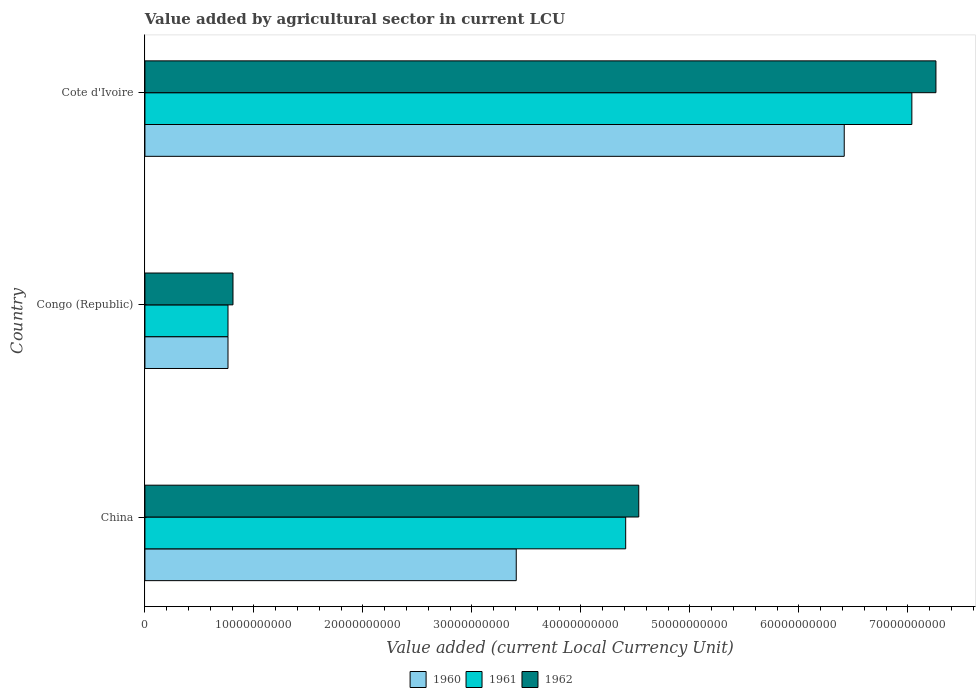Are the number of bars per tick equal to the number of legend labels?
Make the answer very short. Yes. How many bars are there on the 1st tick from the top?
Your answer should be compact. 3. How many bars are there on the 2nd tick from the bottom?
Ensure brevity in your answer.  3. What is the label of the 2nd group of bars from the top?
Your response must be concise. Congo (Republic). What is the value added by agricultural sector in 1960 in China?
Your answer should be compact. 3.41e+1. Across all countries, what is the maximum value added by agricultural sector in 1960?
Your answer should be compact. 6.42e+1. Across all countries, what is the minimum value added by agricultural sector in 1961?
Keep it short and to the point. 7.62e+09. In which country was the value added by agricultural sector in 1961 maximum?
Provide a succinct answer. Cote d'Ivoire. In which country was the value added by agricultural sector in 1961 minimum?
Your answer should be compact. Congo (Republic). What is the total value added by agricultural sector in 1961 in the graph?
Provide a short and direct response. 1.22e+11. What is the difference between the value added by agricultural sector in 1961 in Congo (Republic) and that in Cote d'Ivoire?
Your answer should be very brief. -6.27e+1. What is the difference between the value added by agricultural sector in 1960 in Congo (Republic) and the value added by agricultural sector in 1961 in Cote d'Ivoire?
Give a very brief answer. -6.27e+1. What is the average value added by agricultural sector in 1962 per country?
Your answer should be very brief. 4.20e+1. What is the ratio of the value added by agricultural sector in 1962 in China to that in Congo (Republic)?
Provide a succinct answer. 5.61. What is the difference between the highest and the second highest value added by agricultural sector in 1961?
Offer a very short reply. 2.63e+1. What is the difference between the highest and the lowest value added by agricultural sector in 1962?
Give a very brief answer. 6.45e+1. What does the 1st bar from the top in Cote d'Ivoire represents?
Ensure brevity in your answer.  1962. How many bars are there?
Your response must be concise. 9. Are all the bars in the graph horizontal?
Your answer should be compact. Yes. Does the graph contain grids?
Make the answer very short. No. How are the legend labels stacked?
Your answer should be compact. Horizontal. What is the title of the graph?
Make the answer very short. Value added by agricultural sector in current LCU. What is the label or title of the X-axis?
Keep it short and to the point. Value added (current Local Currency Unit). What is the Value added (current Local Currency Unit) of 1960 in China?
Offer a terse response. 3.41e+1. What is the Value added (current Local Currency Unit) in 1961 in China?
Provide a succinct answer. 4.41e+1. What is the Value added (current Local Currency Unit) of 1962 in China?
Your answer should be very brief. 4.53e+1. What is the Value added (current Local Currency Unit) in 1960 in Congo (Republic)?
Provide a succinct answer. 7.62e+09. What is the Value added (current Local Currency Unit) in 1961 in Congo (Republic)?
Ensure brevity in your answer.  7.62e+09. What is the Value added (current Local Currency Unit) of 1962 in Congo (Republic)?
Offer a very short reply. 8.08e+09. What is the Value added (current Local Currency Unit) in 1960 in Cote d'Ivoire?
Provide a short and direct response. 6.42e+1. What is the Value added (current Local Currency Unit) of 1961 in Cote d'Ivoire?
Your answer should be compact. 7.04e+1. What is the Value added (current Local Currency Unit) in 1962 in Cote d'Ivoire?
Give a very brief answer. 7.26e+1. Across all countries, what is the maximum Value added (current Local Currency Unit) in 1960?
Give a very brief answer. 6.42e+1. Across all countries, what is the maximum Value added (current Local Currency Unit) in 1961?
Make the answer very short. 7.04e+1. Across all countries, what is the maximum Value added (current Local Currency Unit) in 1962?
Give a very brief answer. 7.26e+1. Across all countries, what is the minimum Value added (current Local Currency Unit) in 1960?
Provide a succinct answer. 7.62e+09. Across all countries, what is the minimum Value added (current Local Currency Unit) in 1961?
Provide a succinct answer. 7.62e+09. Across all countries, what is the minimum Value added (current Local Currency Unit) in 1962?
Your answer should be compact. 8.08e+09. What is the total Value added (current Local Currency Unit) of 1960 in the graph?
Make the answer very short. 1.06e+11. What is the total Value added (current Local Currency Unit) in 1961 in the graph?
Provide a short and direct response. 1.22e+11. What is the total Value added (current Local Currency Unit) in 1962 in the graph?
Offer a very short reply. 1.26e+11. What is the difference between the Value added (current Local Currency Unit) in 1960 in China and that in Congo (Republic)?
Ensure brevity in your answer.  2.64e+1. What is the difference between the Value added (current Local Currency Unit) of 1961 in China and that in Congo (Republic)?
Offer a terse response. 3.65e+1. What is the difference between the Value added (current Local Currency Unit) of 1962 in China and that in Congo (Republic)?
Your response must be concise. 3.72e+1. What is the difference between the Value added (current Local Currency Unit) in 1960 in China and that in Cote d'Ivoire?
Keep it short and to the point. -3.01e+1. What is the difference between the Value added (current Local Currency Unit) of 1961 in China and that in Cote d'Ivoire?
Your answer should be very brief. -2.63e+1. What is the difference between the Value added (current Local Currency Unit) in 1962 in China and that in Cote d'Ivoire?
Your response must be concise. -2.73e+1. What is the difference between the Value added (current Local Currency Unit) in 1960 in Congo (Republic) and that in Cote d'Ivoire?
Your answer should be compact. -5.65e+1. What is the difference between the Value added (current Local Currency Unit) in 1961 in Congo (Republic) and that in Cote d'Ivoire?
Provide a succinct answer. -6.27e+1. What is the difference between the Value added (current Local Currency Unit) of 1962 in Congo (Republic) and that in Cote d'Ivoire?
Provide a succinct answer. -6.45e+1. What is the difference between the Value added (current Local Currency Unit) in 1960 in China and the Value added (current Local Currency Unit) in 1961 in Congo (Republic)?
Offer a terse response. 2.64e+1. What is the difference between the Value added (current Local Currency Unit) in 1960 in China and the Value added (current Local Currency Unit) in 1962 in Congo (Republic)?
Offer a terse response. 2.60e+1. What is the difference between the Value added (current Local Currency Unit) in 1961 in China and the Value added (current Local Currency Unit) in 1962 in Congo (Republic)?
Your answer should be compact. 3.60e+1. What is the difference between the Value added (current Local Currency Unit) in 1960 in China and the Value added (current Local Currency Unit) in 1961 in Cote d'Ivoire?
Offer a very short reply. -3.63e+1. What is the difference between the Value added (current Local Currency Unit) in 1960 in China and the Value added (current Local Currency Unit) in 1962 in Cote d'Ivoire?
Provide a short and direct response. -3.85e+1. What is the difference between the Value added (current Local Currency Unit) in 1961 in China and the Value added (current Local Currency Unit) in 1962 in Cote d'Ivoire?
Give a very brief answer. -2.85e+1. What is the difference between the Value added (current Local Currency Unit) in 1960 in Congo (Republic) and the Value added (current Local Currency Unit) in 1961 in Cote d'Ivoire?
Keep it short and to the point. -6.27e+1. What is the difference between the Value added (current Local Currency Unit) of 1960 in Congo (Republic) and the Value added (current Local Currency Unit) of 1962 in Cote d'Ivoire?
Make the answer very short. -6.50e+1. What is the difference between the Value added (current Local Currency Unit) in 1961 in Congo (Republic) and the Value added (current Local Currency Unit) in 1962 in Cote d'Ivoire?
Give a very brief answer. -6.50e+1. What is the average Value added (current Local Currency Unit) of 1960 per country?
Your answer should be very brief. 3.53e+1. What is the average Value added (current Local Currency Unit) of 1961 per country?
Provide a short and direct response. 4.07e+1. What is the average Value added (current Local Currency Unit) of 1962 per country?
Your answer should be compact. 4.20e+1. What is the difference between the Value added (current Local Currency Unit) of 1960 and Value added (current Local Currency Unit) of 1961 in China?
Ensure brevity in your answer.  -1.00e+1. What is the difference between the Value added (current Local Currency Unit) of 1960 and Value added (current Local Currency Unit) of 1962 in China?
Make the answer very short. -1.12e+1. What is the difference between the Value added (current Local Currency Unit) of 1961 and Value added (current Local Currency Unit) of 1962 in China?
Your answer should be compact. -1.20e+09. What is the difference between the Value added (current Local Currency Unit) in 1960 and Value added (current Local Currency Unit) in 1961 in Congo (Republic)?
Provide a short and direct response. 0. What is the difference between the Value added (current Local Currency Unit) of 1960 and Value added (current Local Currency Unit) of 1962 in Congo (Republic)?
Your response must be concise. -4.57e+08. What is the difference between the Value added (current Local Currency Unit) of 1961 and Value added (current Local Currency Unit) of 1962 in Congo (Republic)?
Your response must be concise. -4.57e+08. What is the difference between the Value added (current Local Currency Unit) of 1960 and Value added (current Local Currency Unit) of 1961 in Cote d'Ivoire?
Your response must be concise. -6.21e+09. What is the difference between the Value added (current Local Currency Unit) of 1960 and Value added (current Local Currency Unit) of 1962 in Cote d'Ivoire?
Your answer should be very brief. -8.41e+09. What is the difference between the Value added (current Local Currency Unit) in 1961 and Value added (current Local Currency Unit) in 1962 in Cote d'Ivoire?
Make the answer very short. -2.21e+09. What is the ratio of the Value added (current Local Currency Unit) of 1960 in China to that in Congo (Republic)?
Give a very brief answer. 4.47. What is the ratio of the Value added (current Local Currency Unit) of 1961 in China to that in Congo (Republic)?
Your answer should be compact. 5.79. What is the ratio of the Value added (current Local Currency Unit) of 1962 in China to that in Congo (Republic)?
Give a very brief answer. 5.61. What is the ratio of the Value added (current Local Currency Unit) of 1960 in China to that in Cote d'Ivoire?
Ensure brevity in your answer.  0.53. What is the ratio of the Value added (current Local Currency Unit) in 1961 in China to that in Cote d'Ivoire?
Provide a short and direct response. 0.63. What is the ratio of the Value added (current Local Currency Unit) in 1962 in China to that in Cote d'Ivoire?
Offer a very short reply. 0.62. What is the ratio of the Value added (current Local Currency Unit) in 1960 in Congo (Republic) to that in Cote d'Ivoire?
Your answer should be very brief. 0.12. What is the ratio of the Value added (current Local Currency Unit) in 1961 in Congo (Republic) to that in Cote d'Ivoire?
Keep it short and to the point. 0.11. What is the ratio of the Value added (current Local Currency Unit) in 1962 in Congo (Republic) to that in Cote d'Ivoire?
Provide a short and direct response. 0.11. What is the difference between the highest and the second highest Value added (current Local Currency Unit) in 1960?
Provide a succinct answer. 3.01e+1. What is the difference between the highest and the second highest Value added (current Local Currency Unit) of 1961?
Offer a terse response. 2.63e+1. What is the difference between the highest and the second highest Value added (current Local Currency Unit) of 1962?
Provide a succinct answer. 2.73e+1. What is the difference between the highest and the lowest Value added (current Local Currency Unit) of 1960?
Offer a very short reply. 5.65e+1. What is the difference between the highest and the lowest Value added (current Local Currency Unit) in 1961?
Your answer should be very brief. 6.27e+1. What is the difference between the highest and the lowest Value added (current Local Currency Unit) in 1962?
Your answer should be compact. 6.45e+1. 